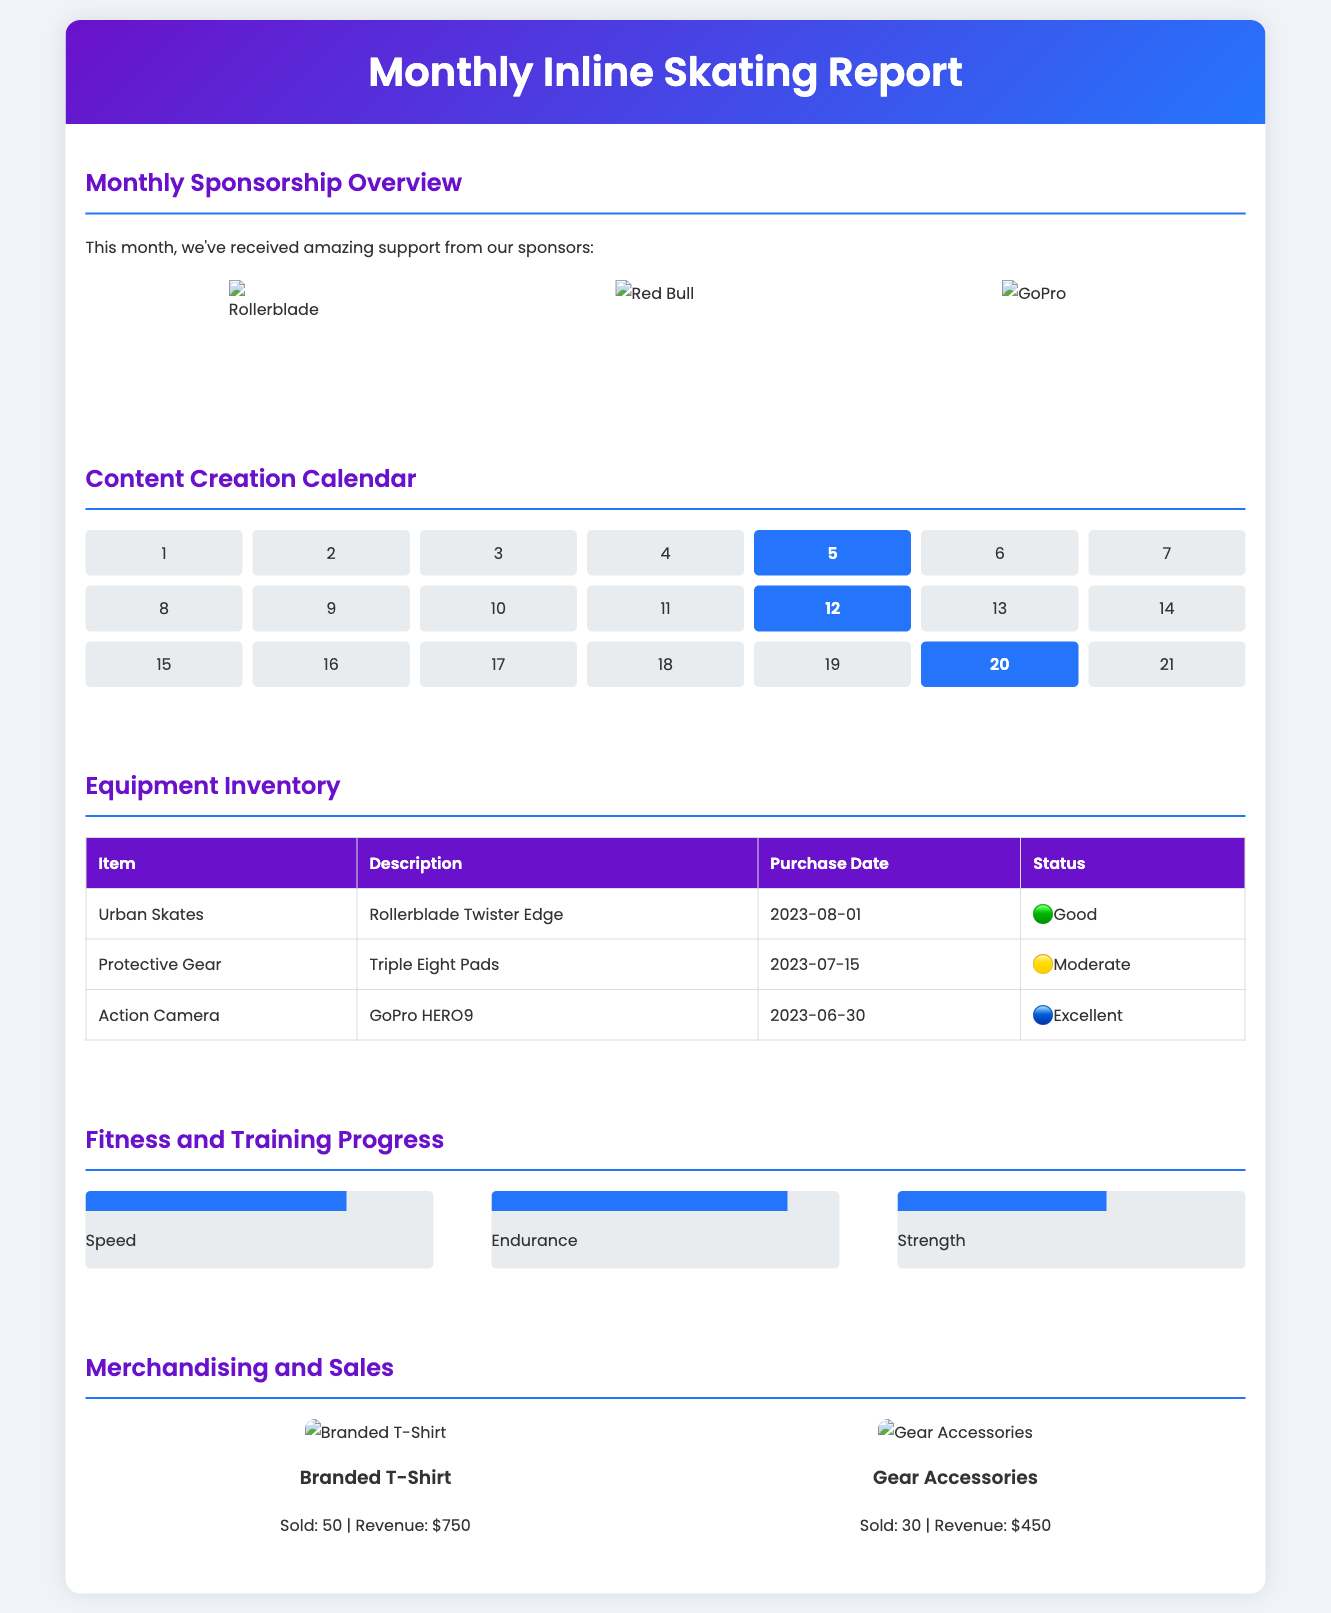What sponsors are featured this month? The document lists three sponsoring companies, which can be seen in the sponsorship section.
Answer: Rollerblade, Red Bull, GoPro How many videos were posted this month? The calendar section indicates three specific days with video uploads.
Answer: 3 What is the condition status of the Urban Skates? The equipment inventory shows that the status of the Urban Skates is categorized under certain color codes, with the Urban Skates rated as "Good".
Answer: Good Which item generated the most revenue? The merchandising section shows that the Branded T-Shirt had the highest sales figure contributing to revenue.
Answer: Branded T-Shirt What percentage indicates strength improvement? The fitness and training progress section shows a percentage for strength which helps quantify improvement.
Answer: 60% How many gear accessories were sold? The merchandising section specifically states the quantity sold for the gear accessories item.
Answer: 30 What date were the Protective Gear purchased? The table in the equipment inventory section provides the purchase date for each item listed, including Protective Gear.
Answer: 2023-07-15 Which training area showed the highest percentage? The progress chart indicates various training areas, and the area with the maximum percentage demonstrates endurance improvement.
Answer: Endurance 